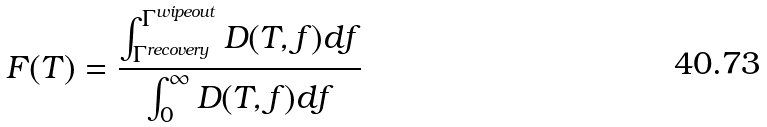Convert formula to latex. <formula><loc_0><loc_0><loc_500><loc_500>F ( T ) = \frac { \int _ { \Gamma ^ { r e c o v e r y } } ^ { \Gamma ^ { w i p e o u t } } D ( T , f ) d f } { \int _ { 0 } ^ { \infty } D ( T , f ) d f }</formula> 